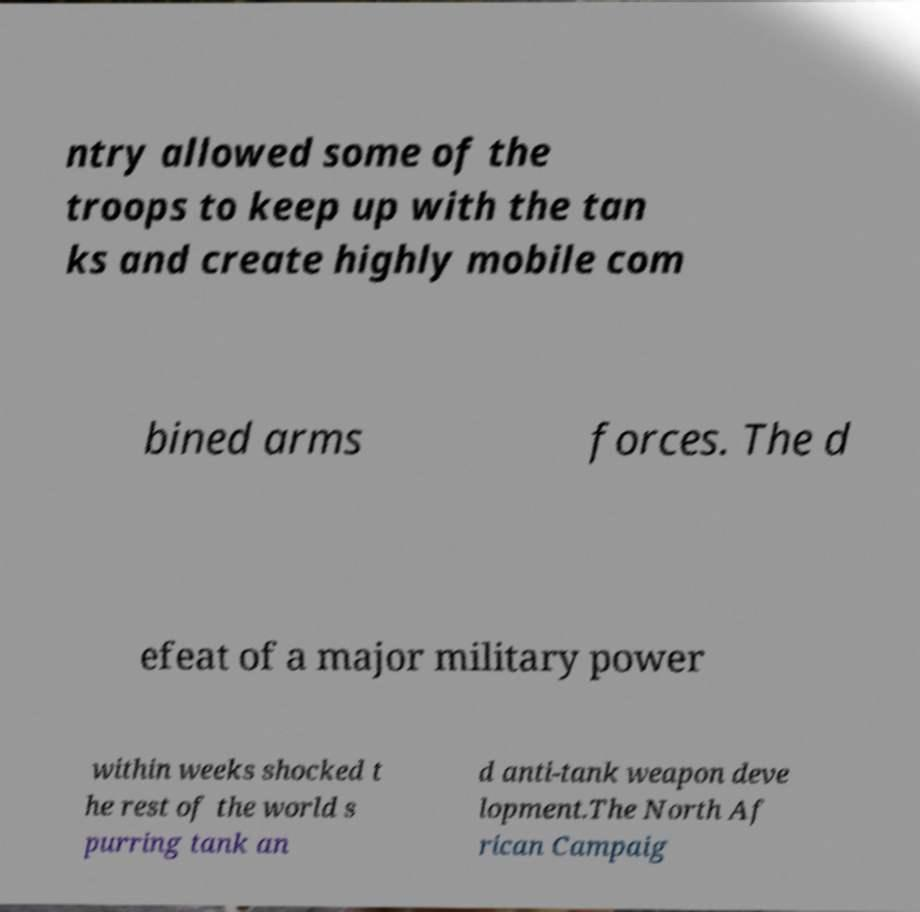Could you extract and type out the text from this image? ntry allowed some of the troops to keep up with the tan ks and create highly mobile com bined arms forces. The d efeat of a major military power within weeks shocked t he rest of the world s purring tank an d anti-tank weapon deve lopment.The North Af rican Campaig 